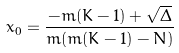Convert formula to latex. <formula><loc_0><loc_0><loc_500><loc_500>x _ { 0 } = \frac { - m ( K - 1 ) + \sqrt { \Delta } } { m ( m ( K - 1 ) - N ) }</formula> 